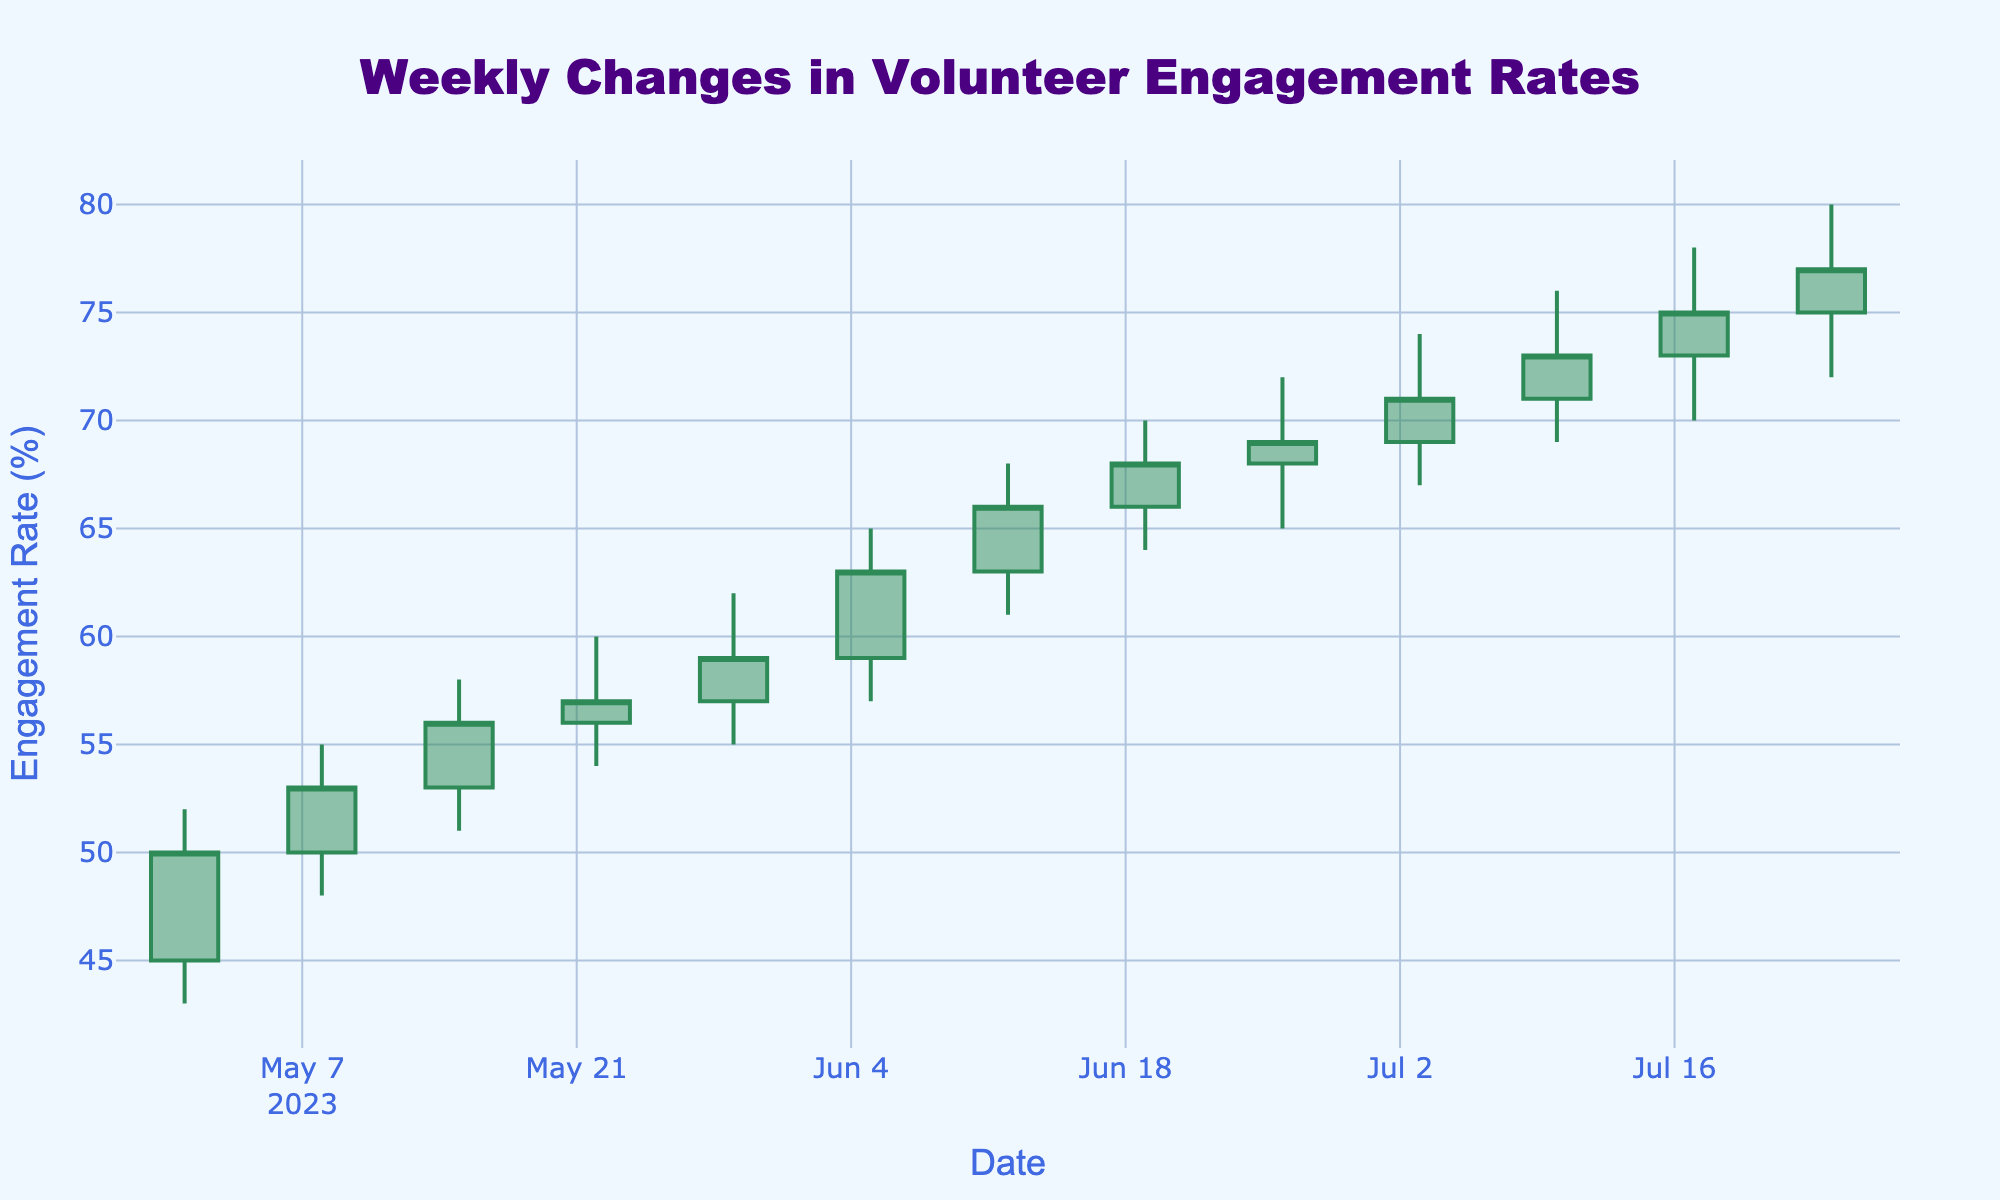What is the title of the figure? The title of the figure is clearly indicated at the top and is centered. It reads "Weekly Changes in Volunteer Engagement Rates" in a prominent font.
Answer: Weekly Changes in Volunteer Engagement Rates How many weeks of data are displayed in the figure? The X-axis represents the date range, and each tick corresponds to a weekly interval starting from 2023-05-01 to 2023-07-24. Counting these intervals gives 12 weeks.
Answer: 12 In which week did the volunteer engagement rate reach its highest value? By examining the highest points on the candlestick chart (the top of the wicks), the highest engagement rate is observed on the week ending 2023-07-24, which reached 80%.
Answer: The week ending 2023-07-24 What was the opening engagement rate in the first recorded week? The opening value can be found in the first candlestick on the chart, which represents the week of 2023-05-01. The open engagement rate here is 45%.
Answer: 45% What is the difference between the highest and lowest engagement rates in the week ending 2023-07-10? The highest rate (top of the wick) is 76%, and the lowest rate (bottom of the wick) is 69%. The difference between these is 76 - 69 = 7%.
Answer: 7% Which color represents increasing volunteer engagement rates? The increasing engagement rates are represented by green candlesticks, which have a sea green color.
Answer: Green On which week did the engagement rate record the lowest closing value? The closing values are found at the end of the candlesticks. The week with the lowest closing value is the first week recorded, ending 2023-05-01, with a closing rate of 50%.
Answer: The week ending 2023-05-01 How does the engagement rate at the end of the period compare to the beginning? The engagement rate at the end (week ending 2023-07-24) is observed to be 77%, while the rate at the beginning (week ending 2023-05-01) is 50%. There is an increase in engagement rate.
Answer: Increased What is the average high engagement rate over the displayed period? To find the average high engagement rate, add up all the high values and divide by the number of weeks: (52 + 55 + 58 + 60 + 62 + 65 + 68 + 70 + 72 + 74 + 76 + 78 + 80) / 12. The sum is 785, and 785 / 12 = 65.42%.
Answer: 65.42% Did any week have an equal open and close engagement rate? By examining the opening and closing values of each candlestick, no week shows an equal value for both open and close rates, indicating that no week had an unchanged engagement rate in this aspect.
Answer: No 